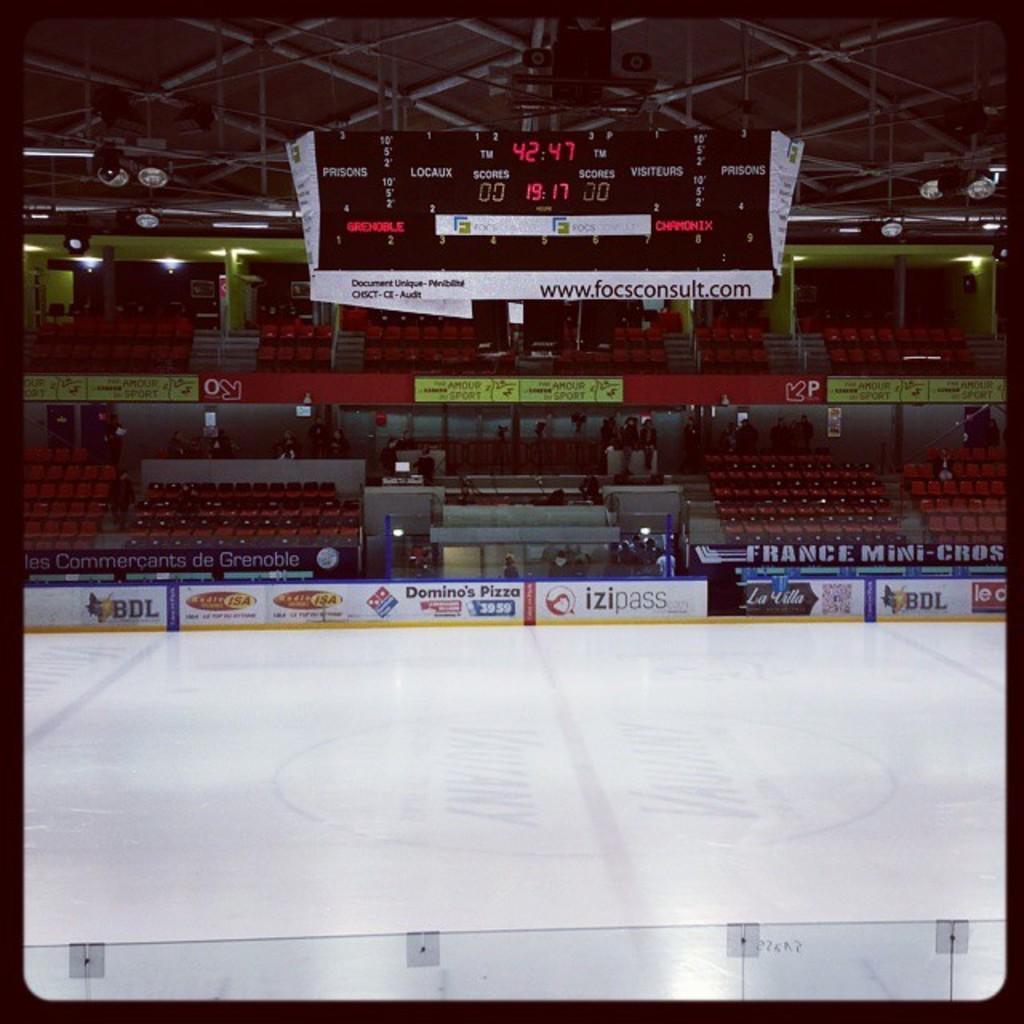How far along are we into the game?
Ensure brevity in your answer.  42:47. 